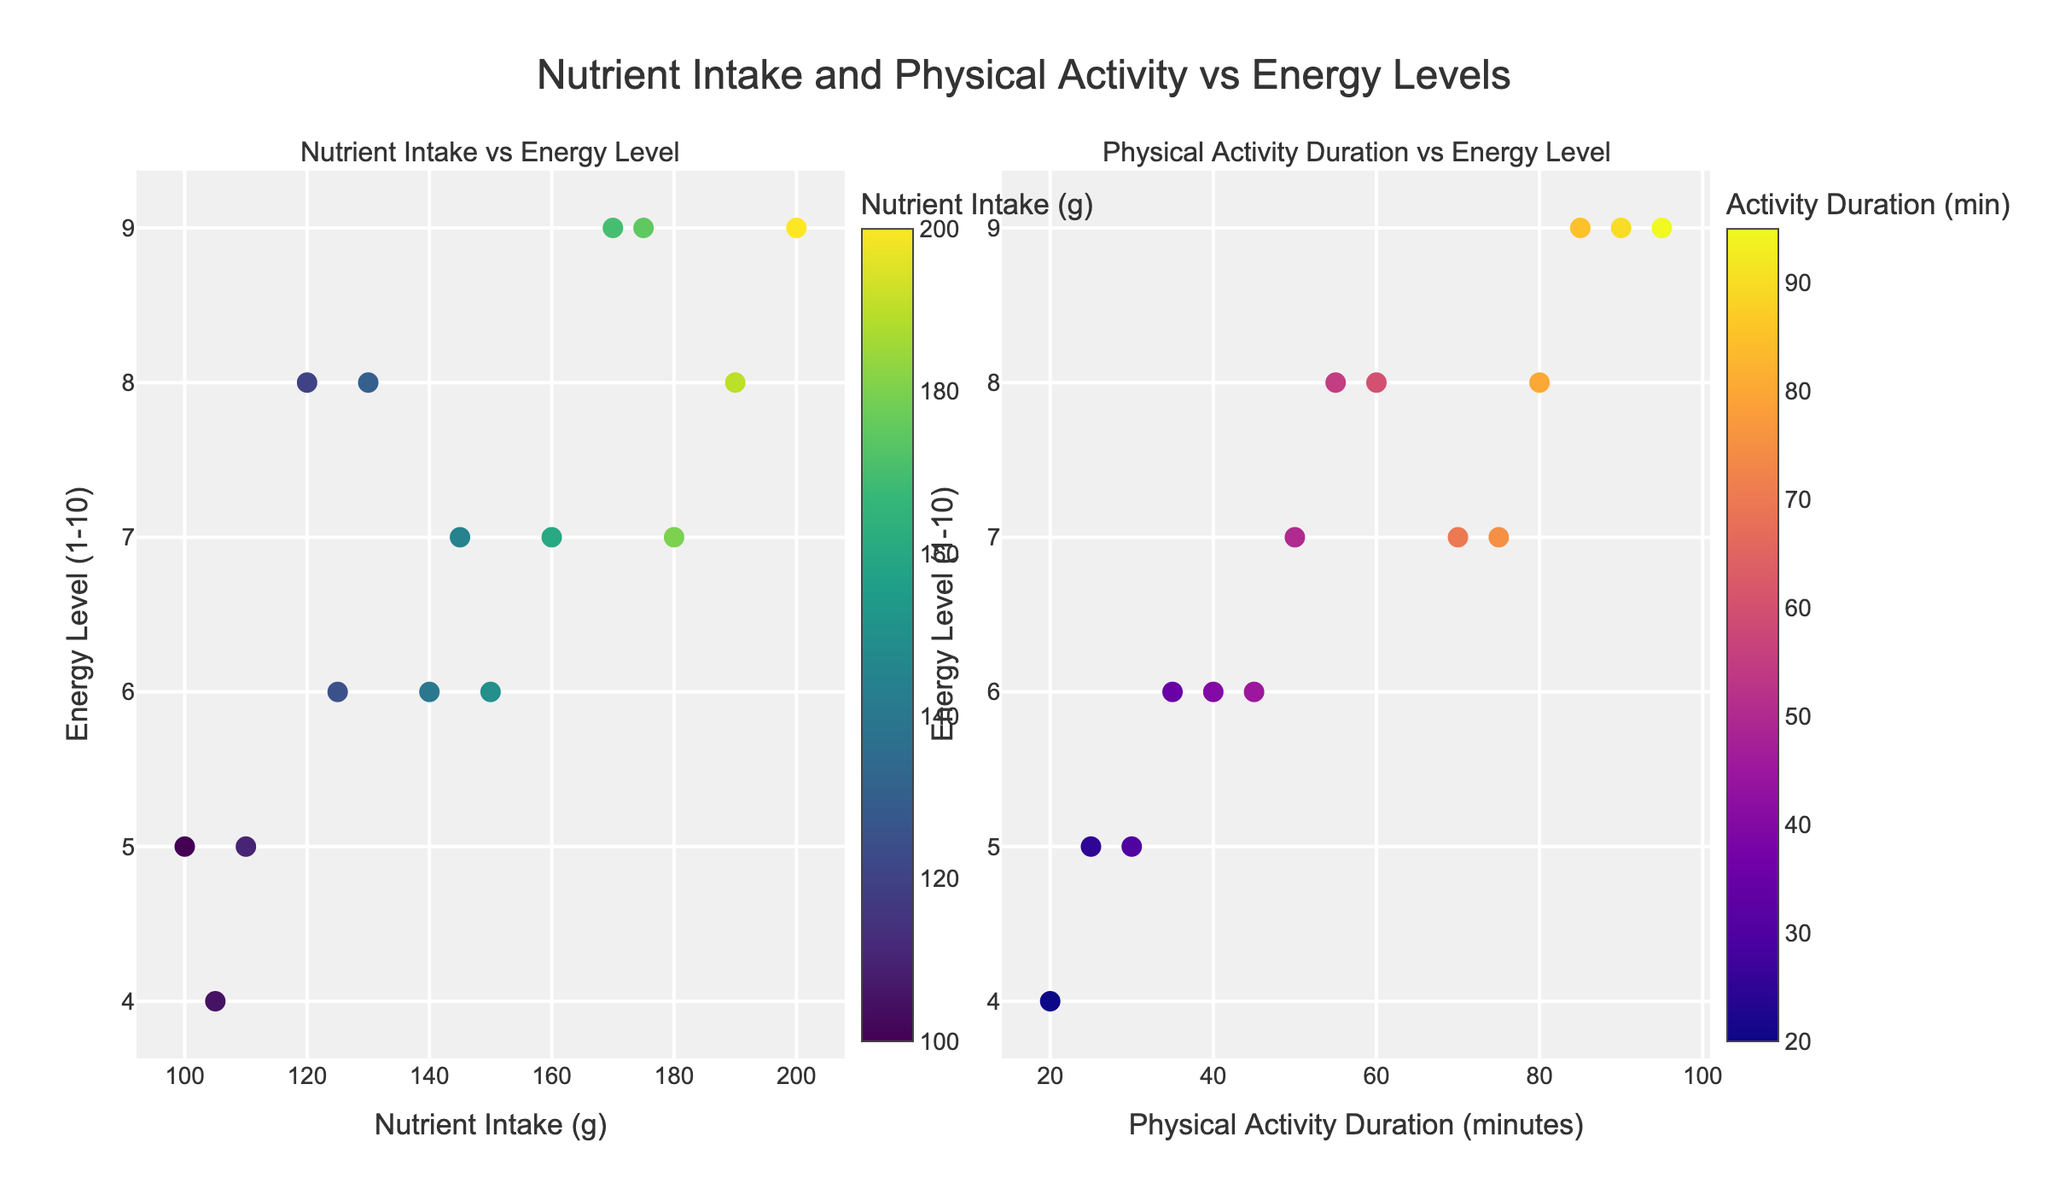What is the title of the figure? The title of the figure is displayed at the top center of the plot. It reads "Nutrient Intake and Physical Activity vs Energy Levels".
Answer: Nutrient Intake and Physical Activity vs Energy Levels How many subplots are in the figure? The figure contains two subplots, as indicated by the layout and the subplot titles "Nutrient Intake vs Energy Level" and "Physical Activity Duration vs Energy Level".
Answer: 2 Which axis is labeled "Nutrient Intake (g)"? The x-axis of the first subplot (left side) is labeled "Nutrient Intake (g)".
Answer: x-axis of the first subplot Which individual has the highest Nutrient Intake? Observing the plot on the left, the highest Nutrient Intake value is marked around 200 grams. The hover information would display the name Emily Johnson for this data point.
Answer: Emily Johnson Which subplot uses the "Plasma" color scale? The subplot on the right labeled "Physical Activity Duration vs Energy Level" uses the "Plasma" color scale for markers.
Answer: Right subplot What is the trend between Nutrient Intake and Energy Level? On examining the left subplot, it can be observed that generally, when Nutrient Intake increases, the Energy Level tends to either stay high or increase as well, suggesting a positive correlation.
Answer: Positive correlation Whose Physical Activity Duration is the longest and what is their Energy Level? From the right subplot, the longest physical activity duration is about 95 minutes, and the corresponding hover text indicates the individual is Daniel Harris with an Energy Level of 9.
Answer: Daniel Harris, Energy Level 9 Compare the Energy Levels of John Smith and Jennifer Davis. According to the hover information, John Smith and Jennifer Davis have Energy Levels of 8 and 7, respectively. John Smith has a higher Energy Level compared to Jennifer Davis.
Answer: John Smith: 8, Jennifer Davis: 7 What is the average Energy Level value across all individuals? The Energy Levels provided are: 8, 6, 9, 5, 7, 8, 6, 9, 5, 7, 8, 6, 4, 9, 7. Sum these values to get 104 and divide by the number of individuals (15). The average is 104/15 ≈ 6.93.
Answer: 6.93 Who has a Nutrient Intake of 150 grams and what is their Energy Level? The hover information on the first subplot shows that Jane Doe has a Nutrient Intake of 150 grams and an Energy Level of 6.
Answer: Jane Doe, Energy Level 6 